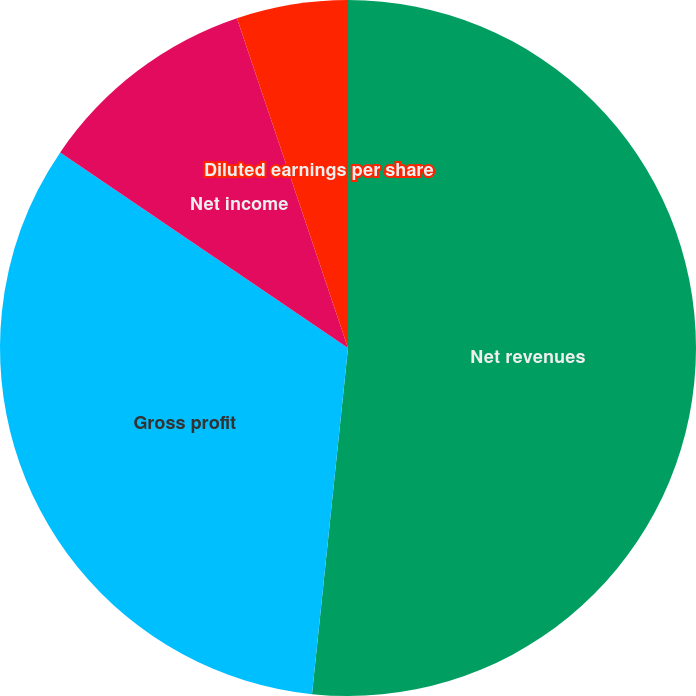Convert chart. <chart><loc_0><loc_0><loc_500><loc_500><pie_chart><fcel>Net revenues<fcel>Gross profit<fcel>Net income<fcel>Basic earnings per share<fcel>Diluted earnings per share<nl><fcel>51.65%<fcel>32.85%<fcel>10.33%<fcel>0.0%<fcel>5.17%<nl></chart> 